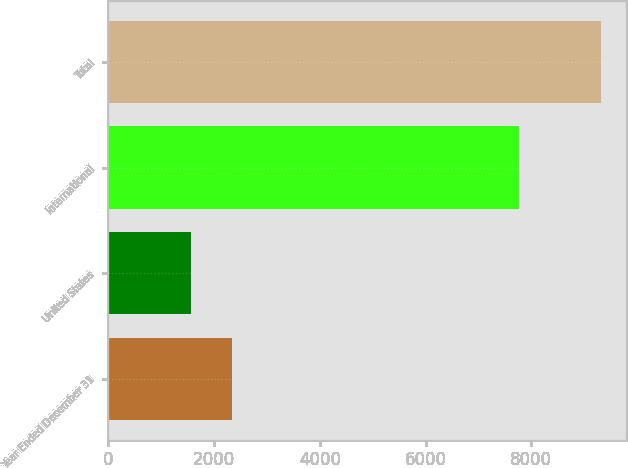Convert chart. <chart><loc_0><loc_0><loc_500><loc_500><bar_chart><fcel>Year Ended December 31<fcel>United States<fcel>International<fcel>Total<nl><fcel>2342.8<fcel>1567<fcel>7758<fcel>9325<nl></chart> 